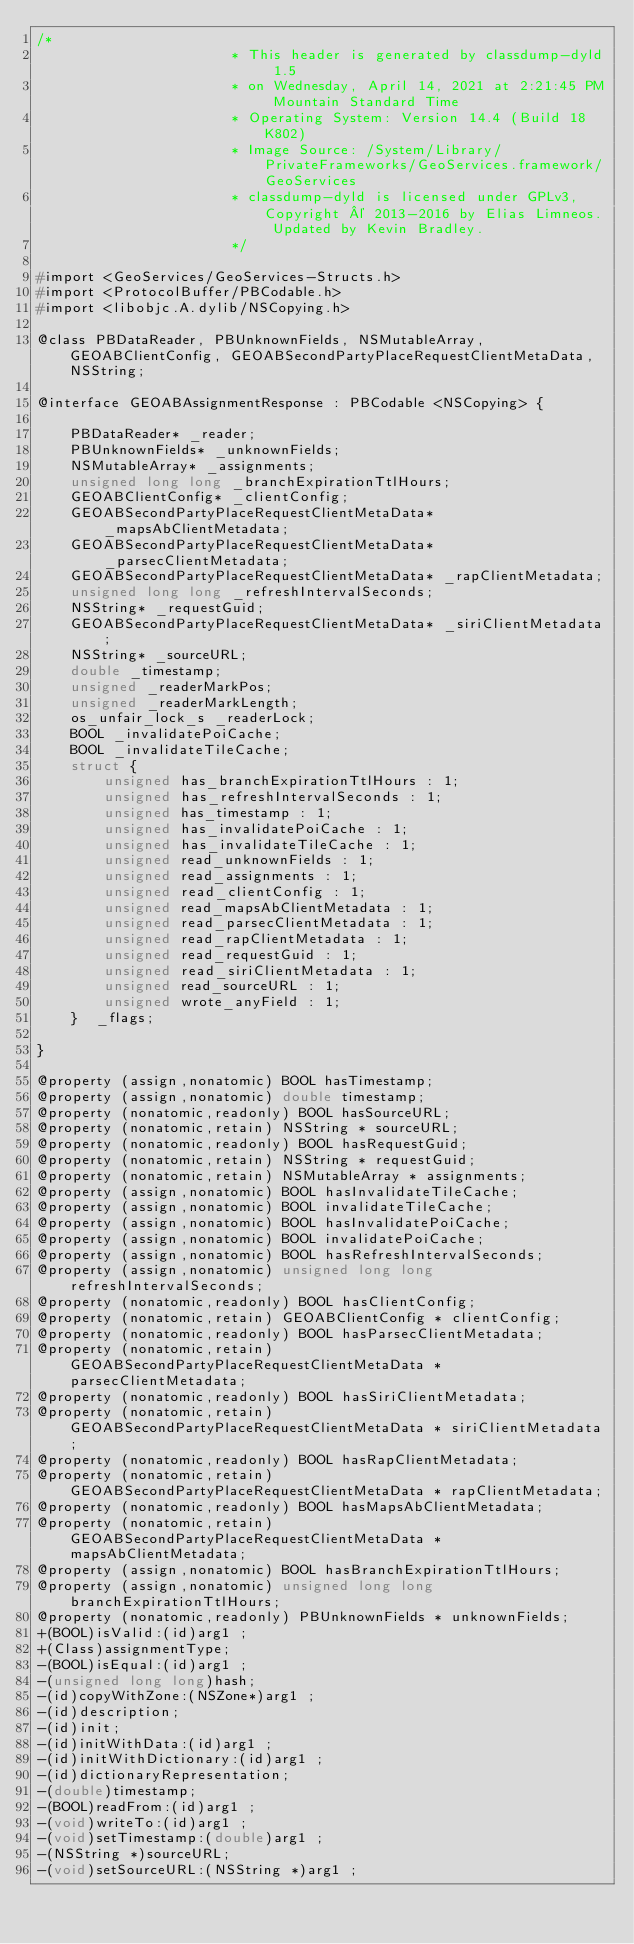<code> <loc_0><loc_0><loc_500><loc_500><_C_>/*
                       * This header is generated by classdump-dyld 1.5
                       * on Wednesday, April 14, 2021 at 2:21:45 PM Mountain Standard Time
                       * Operating System: Version 14.4 (Build 18K802)
                       * Image Source: /System/Library/PrivateFrameworks/GeoServices.framework/GeoServices
                       * classdump-dyld is licensed under GPLv3, Copyright © 2013-2016 by Elias Limneos. Updated by Kevin Bradley.
                       */

#import <GeoServices/GeoServices-Structs.h>
#import <ProtocolBuffer/PBCodable.h>
#import <libobjc.A.dylib/NSCopying.h>

@class PBDataReader, PBUnknownFields, NSMutableArray, GEOABClientConfig, GEOABSecondPartyPlaceRequestClientMetaData, NSString;

@interface GEOABAssignmentResponse : PBCodable <NSCopying> {

	PBDataReader* _reader;
	PBUnknownFields* _unknownFields;
	NSMutableArray* _assignments;
	unsigned long long _branchExpirationTtlHours;
	GEOABClientConfig* _clientConfig;
	GEOABSecondPartyPlaceRequestClientMetaData* _mapsAbClientMetadata;
	GEOABSecondPartyPlaceRequestClientMetaData* _parsecClientMetadata;
	GEOABSecondPartyPlaceRequestClientMetaData* _rapClientMetadata;
	unsigned long long _refreshIntervalSeconds;
	NSString* _requestGuid;
	GEOABSecondPartyPlaceRequestClientMetaData* _siriClientMetadata;
	NSString* _sourceURL;
	double _timestamp;
	unsigned _readerMarkPos;
	unsigned _readerMarkLength;
	os_unfair_lock_s _readerLock;
	BOOL _invalidatePoiCache;
	BOOL _invalidateTileCache;
	struct {
		unsigned has_branchExpirationTtlHours : 1;
		unsigned has_refreshIntervalSeconds : 1;
		unsigned has_timestamp : 1;
		unsigned has_invalidatePoiCache : 1;
		unsigned has_invalidateTileCache : 1;
		unsigned read_unknownFields : 1;
		unsigned read_assignments : 1;
		unsigned read_clientConfig : 1;
		unsigned read_mapsAbClientMetadata : 1;
		unsigned read_parsecClientMetadata : 1;
		unsigned read_rapClientMetadata : 1;
		unsigned read_requestGuid : 1;
		unsigned read_siriClientMetadata : 1;
		unsigned read_sourceURL : 1;
		unsigned wrote_anyField : 1;
	}  _flags;

}

@property (assign,nonatomic) BOOL hasTimestamp; 
@property (assign,nonatomic) double timestamp; 
@property (nonatomic,readonly) BOOL hasSourceURL; 
@property (nonatomic,retain) NSString * sourceURL; 
@property (nonatomic,readonly) BOOL hasRequestGuid; 
@property (nonatomic,retain) NSString * requestGuid; 
@property (nonatomic,retain) NSMutableArray * assignments; 
@property (assign,nonatomic) BOOL hasInvalidateTileCache; 
@property (assign,nonatomic) BOOL invalidateTileCache; 
@property (assign,nonatomic) BOOL hasInvalidatePoiCache; 
@property (assign,nonatomic) BOOL invalidatePoiCache; 
@property (assign,nonatomic) BOOL hasRefreshIntervalSeconds; 
@property (assign,nonatomic) unsigned long long refreshIntervalSeconds; 
@property (nonatomic,readonly) BOOL hasClientConfig; 
@property (nonatomic,retain) GEOABClientConfig * clientConfig; 
@property (nonatomic,readonly) BOOL hasParsecClientMetadata; 
@property (nonatomic,retain) GEOABSecondPartyPlaceRequestClientMetaData * parsecClientMetadata; 
@property (nonatomic,readonly) BOOL hasSiriClientMetadata; 
@property (nonatomic,retain) GEOABSecondPartyPlaceRequestClientMetaData * siriClientMetadata; 
@property (nonatomic,readonly) BOOL hasRapClientMetadata; 
@property (nonatomic,retain) GEOABSecondPartyPlaceRequestClientMetaData * rapClientMetadata; 
@property (nonatomic,readonly) BOOL hasMapsAbClientMetadata; 
@property (nonatomic,retain) GEOABSecondPartyPlaceRequestClientMetaData * mapsAbClientMetadata; 
@property (assign,nonatomic) BOOL hasBranchExpirationTtlHours; 
@property (assign,nonatomic) unsigned long long branchExpirationTtlHours; 
@property (nonatomic,readonly) PBUnknownFields * unknownFields; 
+(BOOL)isValid:(id)arg1 ;
+(Class)assignmentType;
-(BOOL)isEqual:(id)arg1 ;
-(unsigned long long)hash;
-(id)copyWithZone:(NSZone*)arg1 ;
-(id)description;
-(id)init;
-(id)initWithData:(id)arg1 ;
-(id)initWithDictionary:(id)arg1 ;
-(id)dictionaryRepresentation;
-(double)timestamp;
-(BOOL)readFrom:(id)arg1 ;
-(void)writeTo:(id)arg1 ;
-(void)setTimestamp:(double)arg1 ;
-(NSString *)sourceURL;
-(void)setSourceURL:(NSString *)arg1 ;</code> 